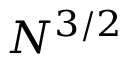<formula> <loc_0><loc_0><loc_500><loc_500>N ^ { 3 / 2 }</formula> 